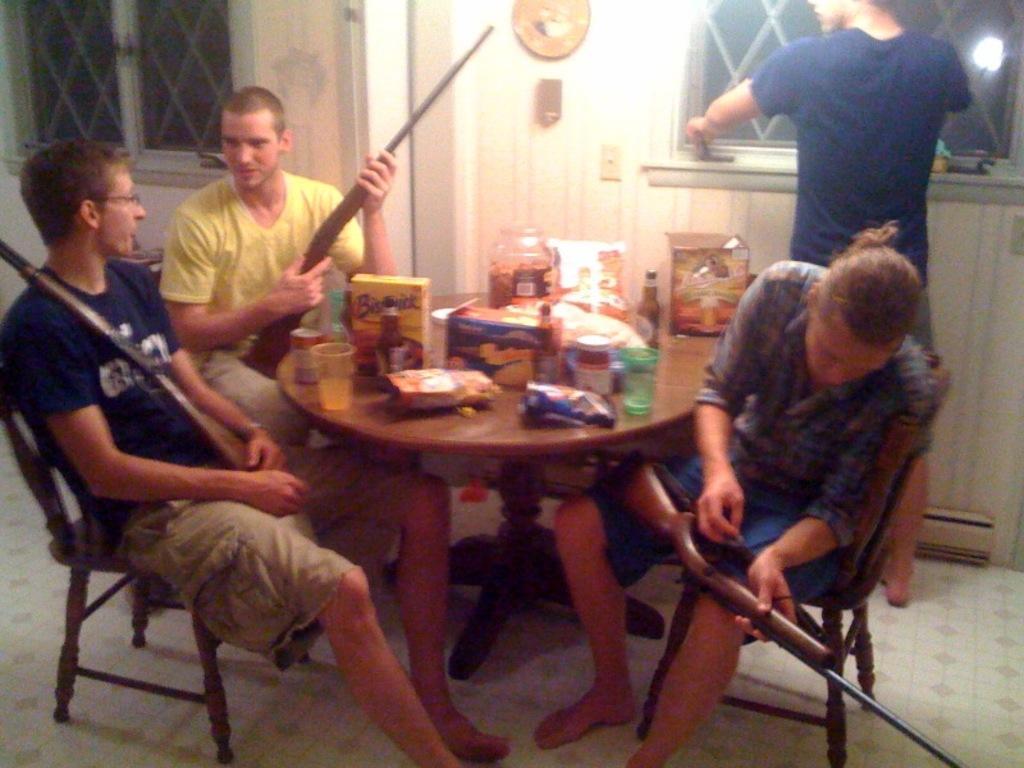How would you summarize this image in a sentence or two? This picture is clicked inside the room. Here, we see three men sitting on chair are holding gun in their hands. Beside, in front of them, we see a table on which glass, coke bottle, jam bottle, wine bottle, plastic box and cotton box are placed on it. Behind that, we see a white door and beside the door, we see a window and on the right corner picture, man in blue t-shirt standing near the window. 